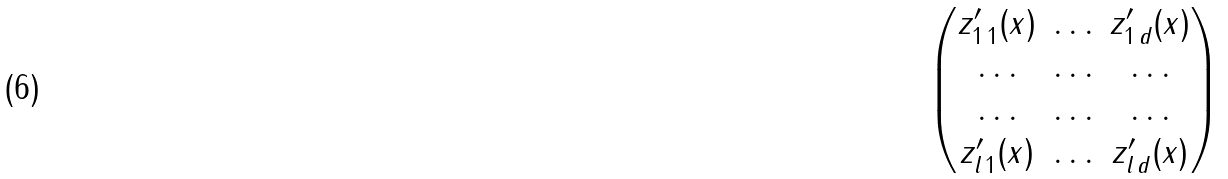<formula> <loc_0><loc_0><loc_500><loc_500>\begin{pmatrix} z ^ { \prime } _ { 1 \, 1 } ( x ) & \hdots & z ^ { \prime } _ { 1 \, d } ( x ) \\ \hdots & \hdots & \hdots \\ \hdots & \hdots & \hdots \\ z ^ { \prime } _ { l \, 1 } ( x ) & \hdots & z ^ { \prime } _ { l \, d } ( x ) \end{pmatrix}</formula> 